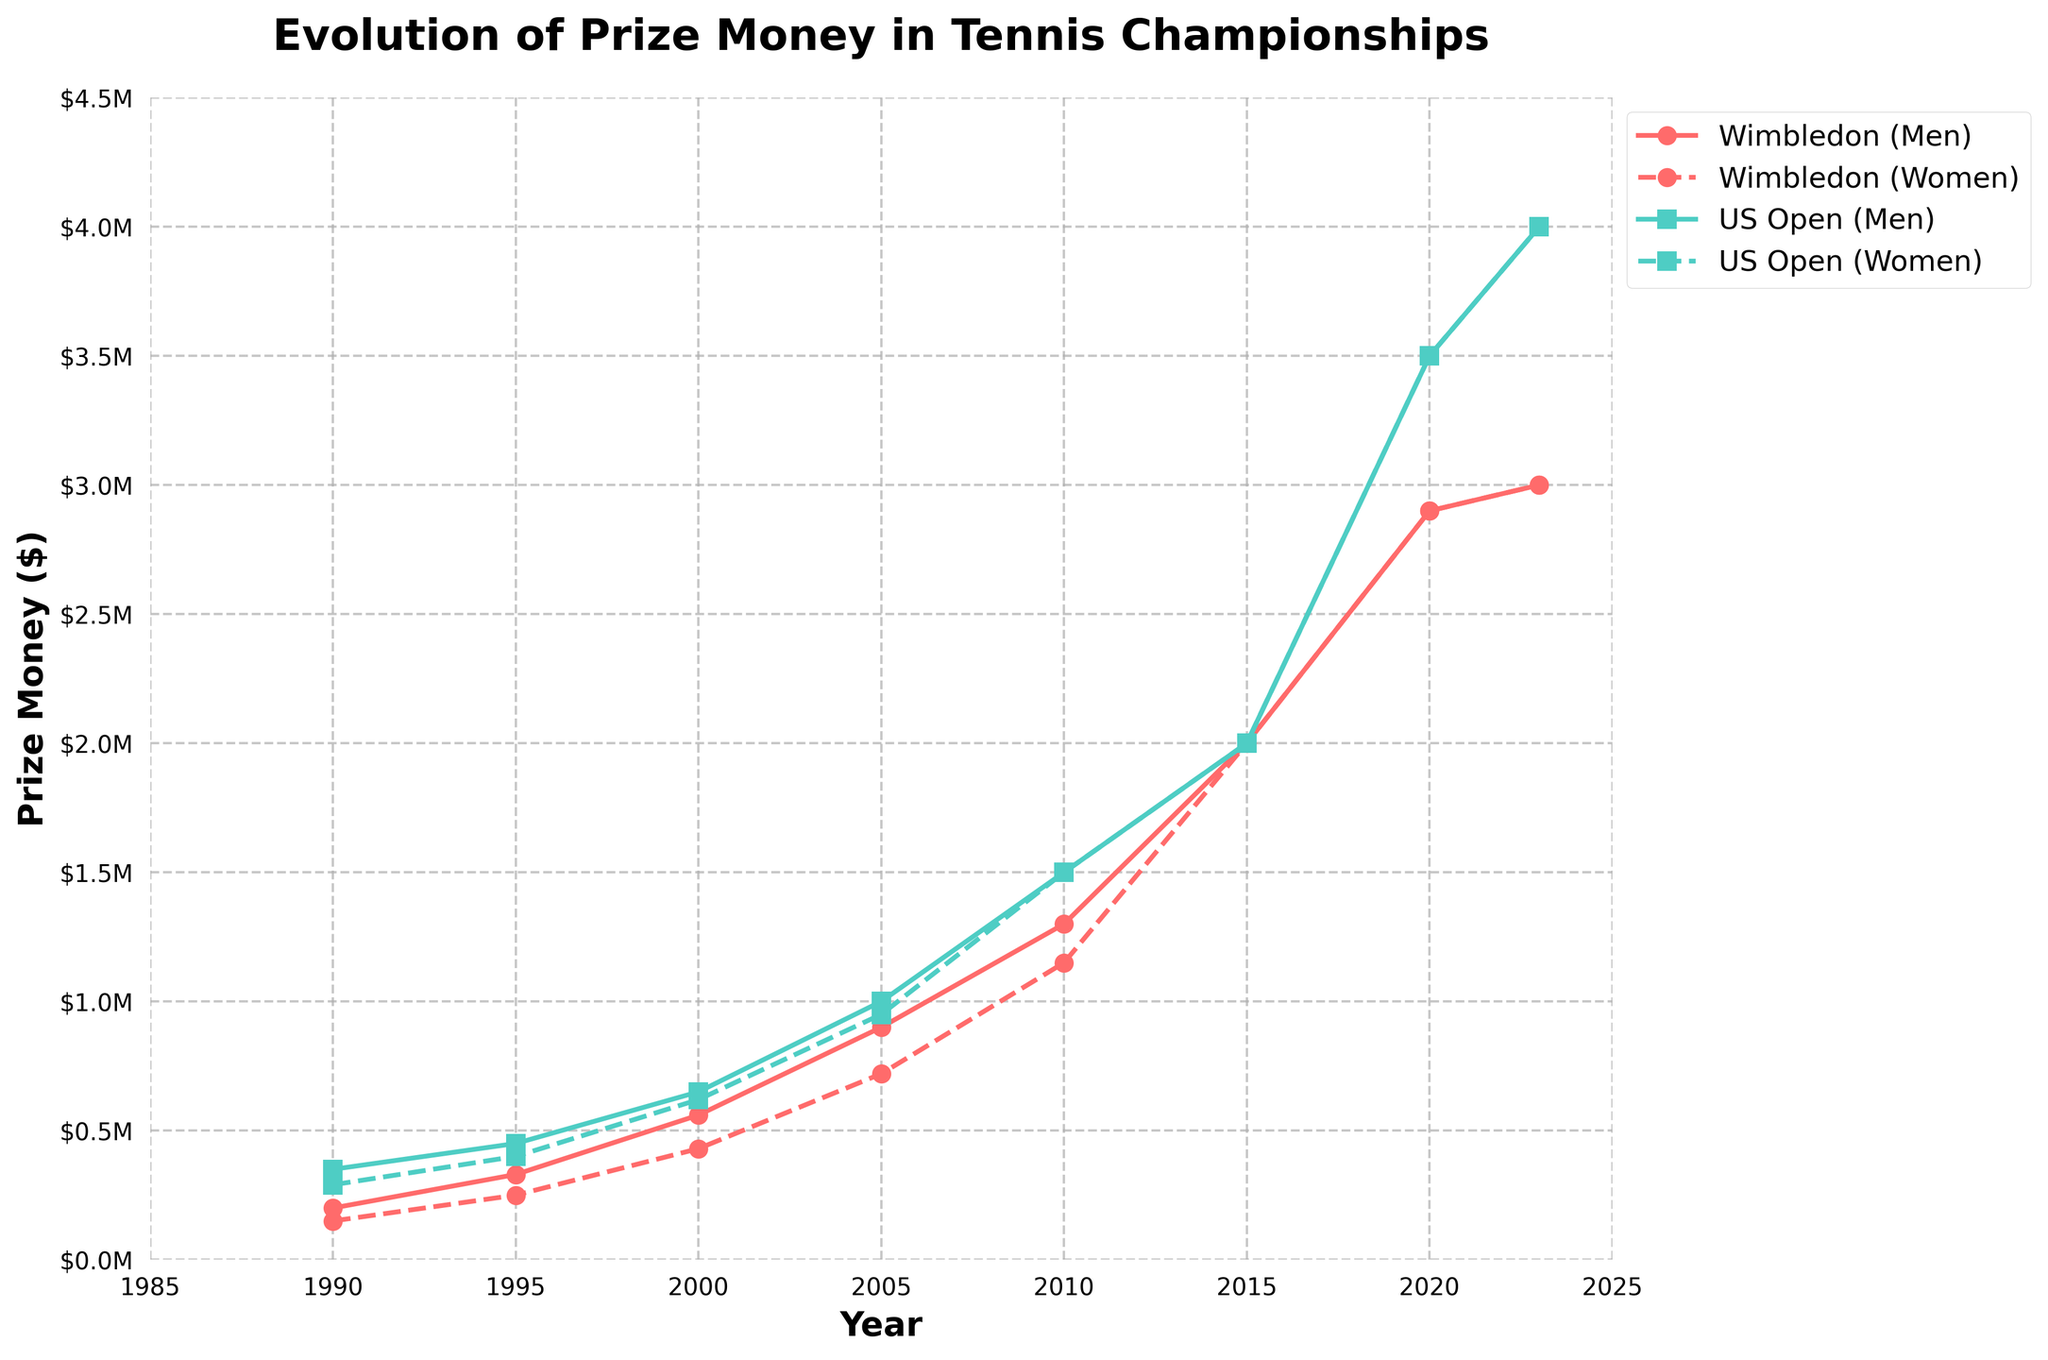what's the title of the plot? The title is displayed above the figure and usually summarizes the main point of the plot in a few words. In this case, it reads "Evolution of Prize Money in Tennis Championships", as described in the code.
Answer: Evolution of Prize Money in Tennis Championships how many events are depicted in the plot? The figure shows two distinct sets of data, with each set represented by different lines. The labels for these lines indicate that there are two events: Wimbledon and US Open.
Answer: 2 what was the prize money disparity between men's and women's Wimbledon in 1990? To find the disparity, subtract the women's prize money from the men's prize money for Wimbledon in 1990. Men's prize money was $200,000, and women's was $150,000. So, $200,000 - $150,000 = $50,000.
Answer: $50,000 in which year did the prize money for men and women become equal for both events? By looking at the points where the lines for men's and women's prize money intersect, we can see that prize money for both genders became equal in 2015 for both Wimbledon and US Open.
Answer: 2015 how did the men's prize money for Wimbledon change from 2000 to 2020? The men's prize money for Wimbledon in 2000 was $560,000, and in 2020 it was $2,900,000. Subtract the 2000 value from the 2020 value to determine the change: $2,900,000 - $560,000 = $2,340,000.
Answer: $2,340,000 which event had a higher prize money for women in 2023? Compare the women's prize money for Wimbledon and the US Open in 2023 based on the figure. The US Open had $4,000,000, whereas Wimbledon had $3,000,000.
Answer: US Open how many years did it take for the women's US Open prize money to reach parity with the men's? Women's prize money became equal to men's in 2010. Initially, in 1990, the prize money for women was $290,000 versus $350,000 for men. The number of years taken is 2010 - 1990 = 20 years.
Answer: 20 years what's the average prize money for men and women in the US Open over the years? To calculate the average prize money, sum the prize money amounts over the years for each gender and divide by the number of data points (7). For men: ($350,000 + $450,000 + $650,000 + $1,000,000 + $1,500,000 + $2,000,000 + $3,500,000 + $4,000,000) / 7 = $10,450,000 / 8 ≈ $1,306,250. For women: ($290,000 + $400,000 + $620,000 + $950,000 + $1,500,000 + $2,000,000 + $3,500,000 + $4,000,000) / 7 ≈ $1,282,500.
Answer: $1,306,250 (Men), $1,282,500 (Women) did any event reach $1,000,000 prize money for women before 2005? Examine the plot to see the timeline for when the women's prize money reached $1,000,000. Neither event reached $1,000,000 before 2005; the earliest instance was in the 2005 US Open.
Answer: No which event had the largest prize money increase for women from 1995 to 2000? Compare the changes in prize money from 1995 to 2000 for both Wimbledon and the US Open. Wimbledon increased from $250,000 to $430,000, a $180,000 increase. The US Open increased from $400,000 to $620,000, a $220,000 increase.
Answer: US Open 